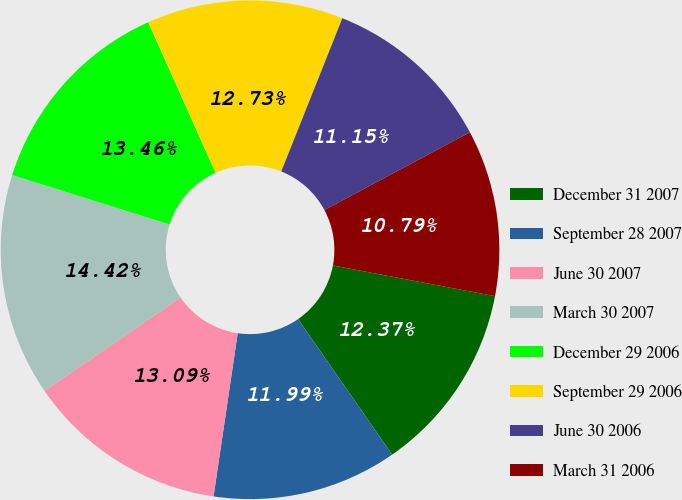<chart> <loc_0><loc_0><loc_500><loc_500><pie_chart><fcel>December 31 2007<fcel>September 28 2007<fcel>June 30 2007<fcel>March 30 2007<fcel>December 29 2006<fcel>September 29 2006<fcel>June 30 2006<fcel>March 31 2006<nl><fcel>12.37%<fcel>11.99%<fcel>13.09%<fcel>14.42%<fcel>13.46%<fcel>12.73%<fcel>11.15%<fcel>10.79%<nl></chart> 